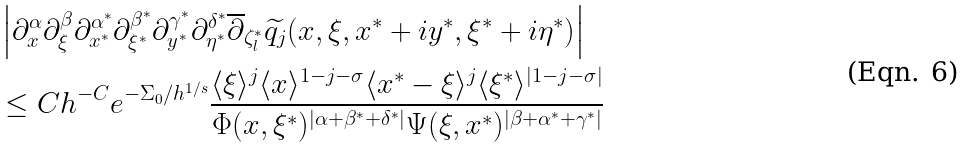<formula> <loc_0><loc_0><loc_500><loc_500>& \left | \partial _ { x } ^ { \alpha } \partial _ { \xi } ^ { \beta } \partial _ { x ^ { * } } ^ { \alpha ^ { * } } \partial _ { \xi ^ { * } } ^ { \beta ^ { * } } \partial _ { y ^ { * } } ^ { \gamma ^ { * } } \partial _ { \eta ^ { * } } ^ { \delta ^ { * } } \overline { \partial } _ { \zeta _ { l } ^ { * } } \widetilde { q _ { j } } ( x , \xi , x ^ { * } + i y ^ { * } , \xi ^ { * } + i \eta ^ { * } ) \right | \\ & \leq C h ^ { - C } e ^ { - \Sigma _ { 0 } / h ^ { 1 / s } } \frac { \langle \xi \rangle ^ { j } \langle x \rangle ^ { 1 - j - \sigma } \langle x ^ { * } - \xi \rangle ^ { j } \langle \xi ^ { * } \rangle ^ { | 1 - j - \sigma | } } { \Phi ( x , \xi ^ { * } ) ^ { | \alpha + \beta ^ { * } + \delta ^ { * } | } \Psi ( \xi , x ^ { * } ) ^ { | \beta + \alpha ^ { * } + \gamma ^ { * } | } }</formula> 